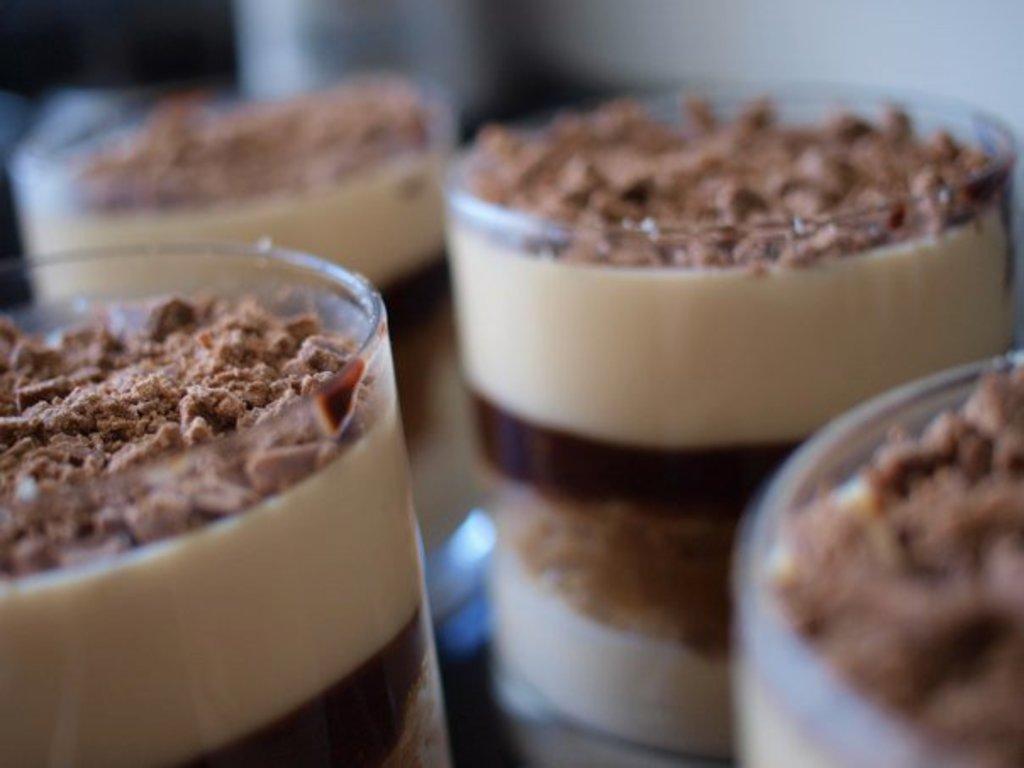Could you give a brief overview of what you see in this image? In the center of the image we can see a few glasses. In the glasses, we can see the black forest chocolate coffee. In the background, we can see it is blurred. 